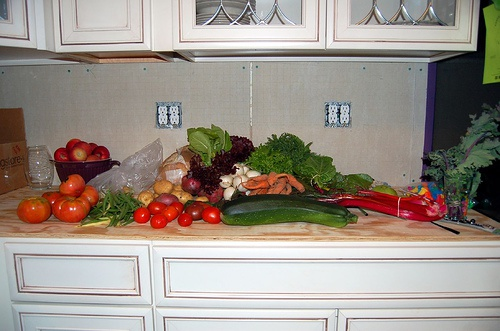Describe the objects in this image and their specific colors. I can see bottle in purple, gray, and maroon tones, bowl in purple, black, maroon, and gray tones, carrot in purple, brown, red, and maroon tones, apple in purple, maroon, brown, and gray tones, and carrot in purple, brown, red, and maroon tones in this image. 